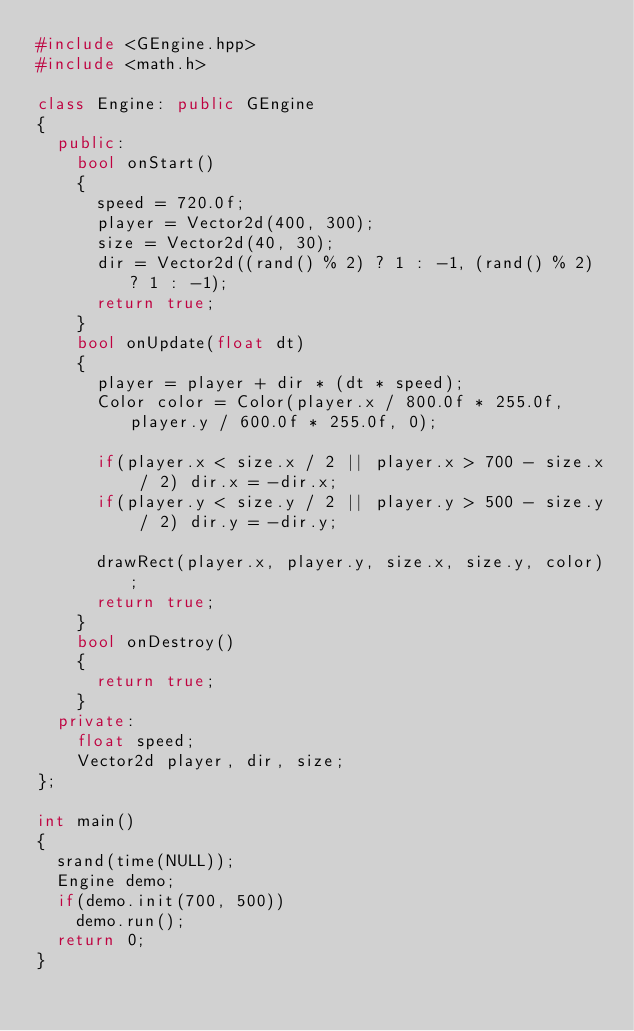<code> <loc_0><loc_0><loc_500><loc_500><_C++_>#include <GEngine.hpp>
#include <math.h>

class Engine: public GEngine
{
	public:
		bool onStart()
		{
			speed = 720.0f;
			player = Vector2d(400, 300);
			size = Vector2d(40, 30);
			dir = Vector2d((rand() % 2) ? 1 : -1, (rand() % 2) ? 1 : -1);
			return true;
		}
		bool onUpdate(float dt)
		{
			player = player + dir * (dt * speed);
			Color color = Color(player.x / 800.0f * 255.0f, player.y / 600.0f * 255.0f, 0);
			
			if(player.x < size.x / 2 || player.x > 700 - size.x / 2) dir.x = -dir.x;
			if(player.y < size.y / 2 || player.y > 500 - size.y / 2) dir.y = -dir.y;

			drawRect(player.x, player.y, size.x, size.y, color);
			return true;
		}
		bool onDestroy()
		{
			return true;
		}
	private:
		float speed;
		Vector2d player, dir, size;
};

int main()
{
	srand(time(NULL));
	Engine demo;
	if(demo.init(700, 500))
		demo.run();
	return 0;
}
</code> 